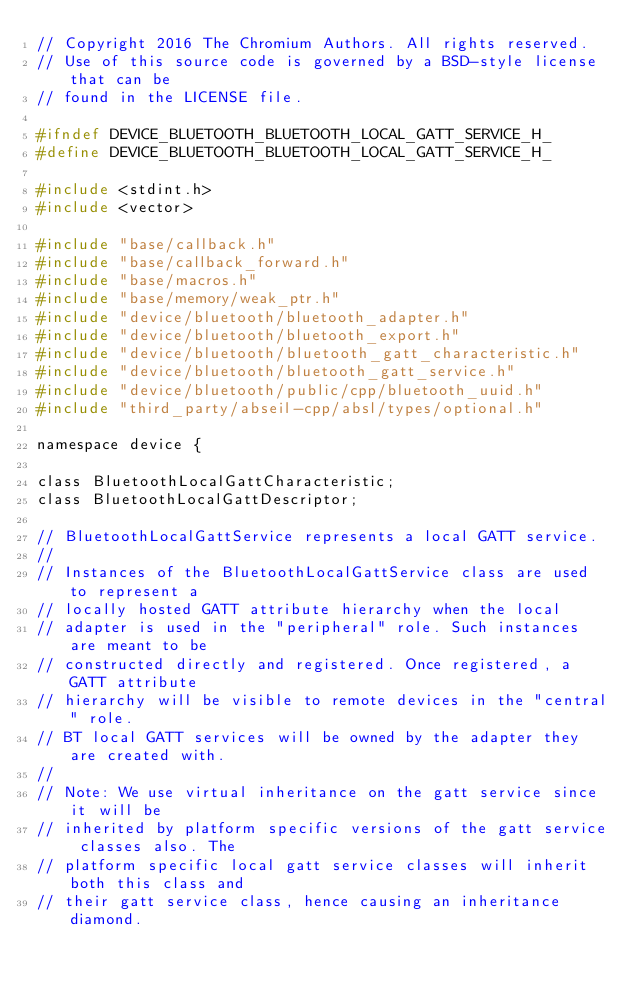<code> <loc_0><loc_0><loc_500><loc_500><_C_>// Copyright 2016 The Chromium Authors. All rights reserved.
// Use of this source code is governed by a BSD-style license that can be
// found in the LICENSE file.

#ifndef DEVICE_BLUETOOTH_BLUETOOTH_LOCAL_GATT_SERVICE_H_
#define DEVICE_BLUETOOTH_BLUETOOTH_LOCAL_GATT_SERVICE_H_

#include <stdint.h>
#include <vector>

#include "base/callback.h"
#include "base/callback_forward.h"
#include "base/macros.h"
#include "base/memory/weak_ptr.h"
#include "device/bluetooth/bluetooth_adapter.h"
#include "device/bluetooth/bluetooth_export.h"
#include "device/bluetooth/bluetooth_gatt_characteristic.h"
#include "device/bluetooth/bluetooth_gatt_service.h"
#include "device/bluetooth/public/cpp/bluetooth_uuid.h"
#include "third_party/abseil-cpp/absl/types/optional.h"

namespace device {

class BluetoothLocalGattCharacteristic;
class BluetoothLocalGattDescriptor;

// BluetoothLocalGattService represents a local GATT service.
//
// Instances of the BluetoothLocalGattService class are used to represent a
// locally hosted GATT attribute hierarchy when the local
// adapter is used in the "peripheral" role. Such instances are meant to be
// constructed directly and registered. Once registered, a GATT attribute
// hierarchy will be visible to remote devices in the "central" role.
// BT local GATT services will be owned by the adapter they are created with.
//
// Note: We use virtual inheritance on the gatt service since it will be
// inherited by platform specific versions of the gatt service classes also. The
// platform specific local gatt service classes will inherit both this class and
// their gatt service class, hence causing an inheritance diamond.</code> 